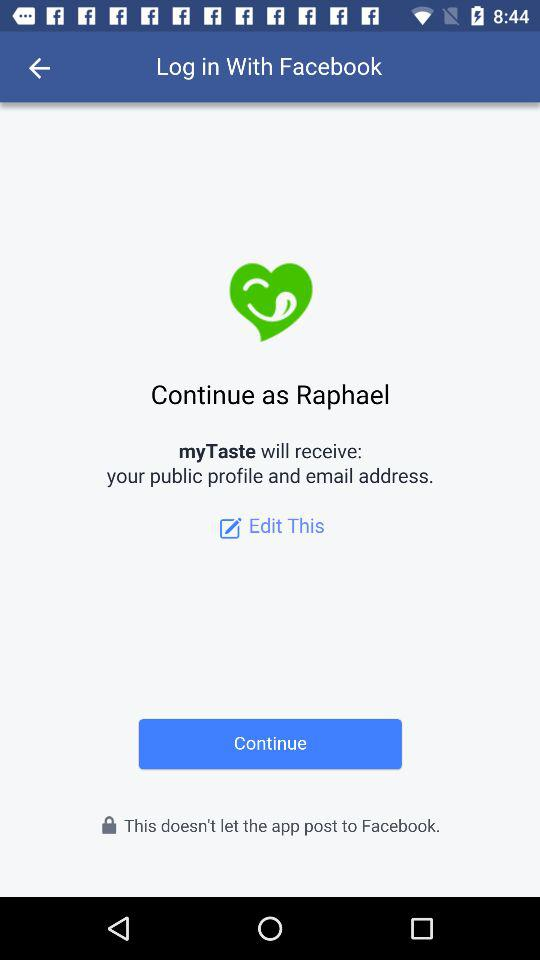What is received by the application "myTaste"? The application "myTaste" will receive your "public profile and email address". 